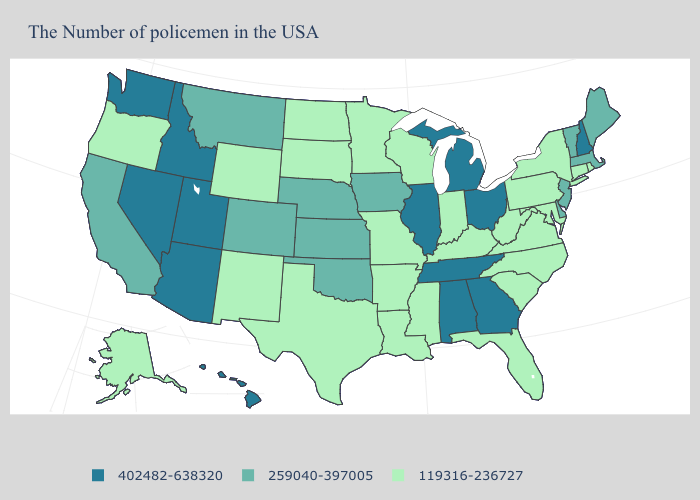Which states have the highest value in the USA?
Write a very short answer. New Hampshire, Ohio, Georgia, Michigan, Alabama, Tennessee, Illinois, Utah, Arizona, Idaho, Nevada, Washington, Hawaii. What is the value of Alabama?
Be succinct. 402482-638320. What is the highest value in the West ?
Answer briefly. 402482-638320. Does Idaho have the highest value in the USA?
Concise answer only. Yes. Among the states that border Pennsylvania , which have the lowest value?
Quick response, please. New York, Maryland, West Virginia. What is the highest value in states that border Delaware?
Write a very short answer. 259040-397005. Name the states that have a value in the range 402482-638320?
Give a very brief answer. New Hampshire, Ohio, Georgia, Michigan, Alabama, Tennessee, Illinois, Utah, Arizona, Idaho, Nevada, Washington, Hawaii. Does New York have the highest value in the Northeast?
Write a very short answer. No. What is the lowest value in the Northeast?
Quick response, please. 119316-236727. What is the value of Kentucky?
Keep it brief. 119316-236727. Does Colorado have the highest value in the West?
Short answer required. No. Is the legend a continuous bar?
Short answer required. No. Name the states that have a value in the range 402482-638320?
Be succinct. New Hampshire, Ohio, Georgia, Michigan, Alabama, Tennessee, Illinois, Utah, Arizona, Idaho, Nevada, Washington, Hawaii. What is the value of Delaware?
Quick response, please. 259040-397005. 